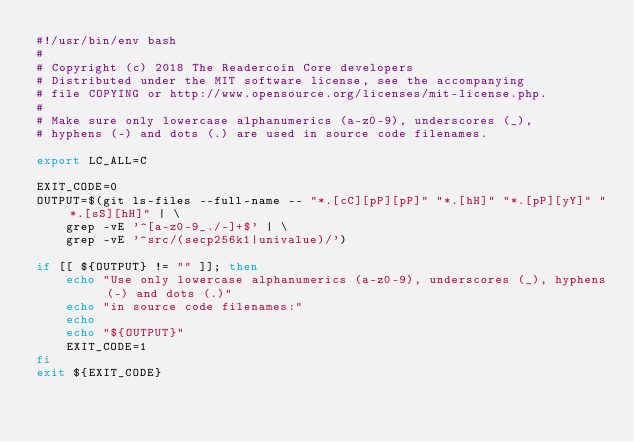Convert code to text. <code><loc_0><loc_0><loc_500><loc_500><_Bash_>#!/usr/bin/env bash
#
# Copyright (c) 2018 The Readercoin Core developers
# Distributed under the MIT software license, see the accompanying
# file COPYING or http://www.opensource.org/licenses/mit-license.php.
#
# Make sure only lowercase alphanumerics (a-z0-9), underscores (_),
# hyphens (-) and dots (.) are used in source code filenames.

export LC_ALL=C

EXIT_CODE=0
OUTPUT=$(git ls-files --full-name -- "*.[cC][pP][pP]" "*.[hH]" "*.[pP][yY]" "*.[sS][hH]" | \
    grep -vE '^[a-z0-9_./-]+$' | \
    grep -vE '^src/(secp256k1|univalue)/')

if [[ ${OUTPUT} != "" ]]; then
    echo "Use only lowercase alphanumerics (a-z0-9), underscores (_), hyphens (-) and dots (.)"
    echo "in source code filenames:"
    echo
    echo "${OUTPUT}"
    EXIT_CODE=1
fi
exit ${EXIT_CODE}
</code> 